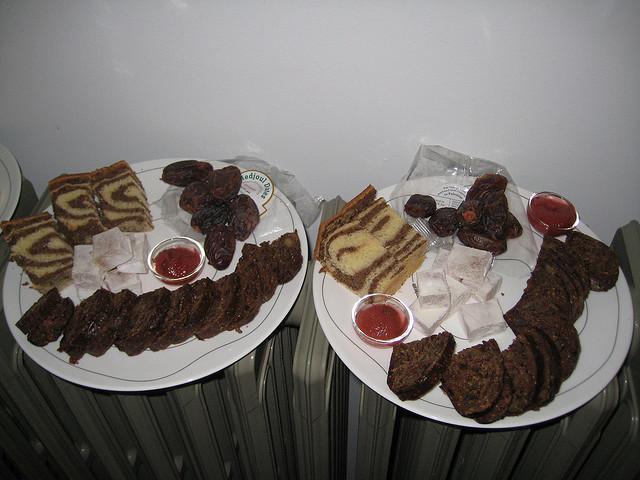How many bowls are there?
Give a very brief answer. 3. How many cakes are visible?
Give a very brief answer. 8. How many people in the photo?
Give a very brief answer. 0. 